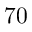Convert formula to latex. <formula><loc_0><loc_0><loc_500><loc_500>7 0</formula> 